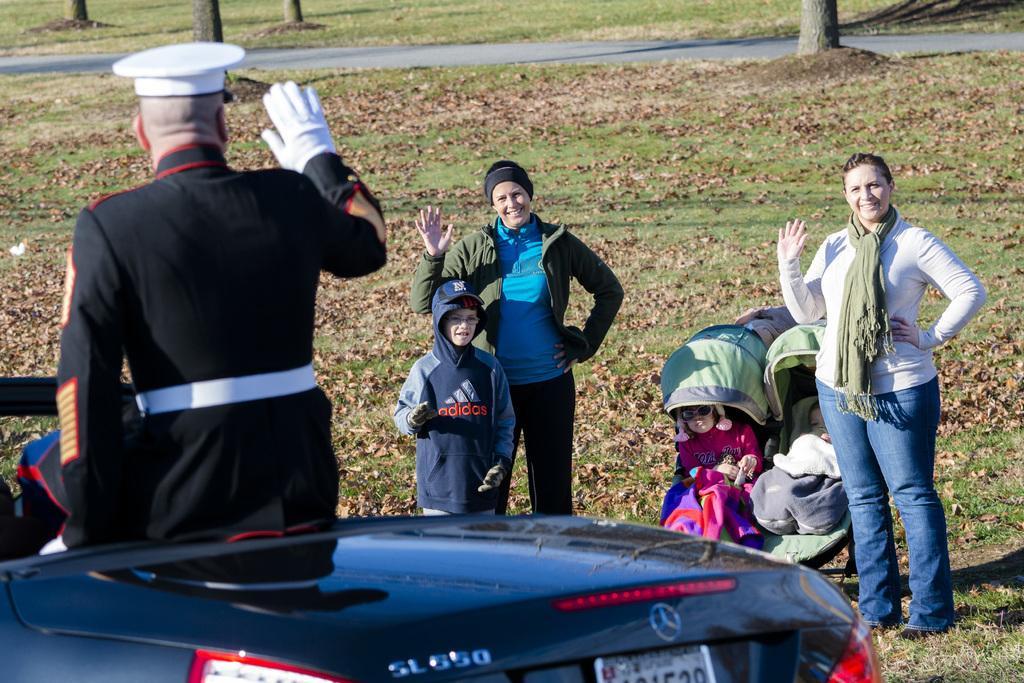In one or two sentences, can you explain what this image depicts? As we can see in the image there is grass, car and few people over here. 